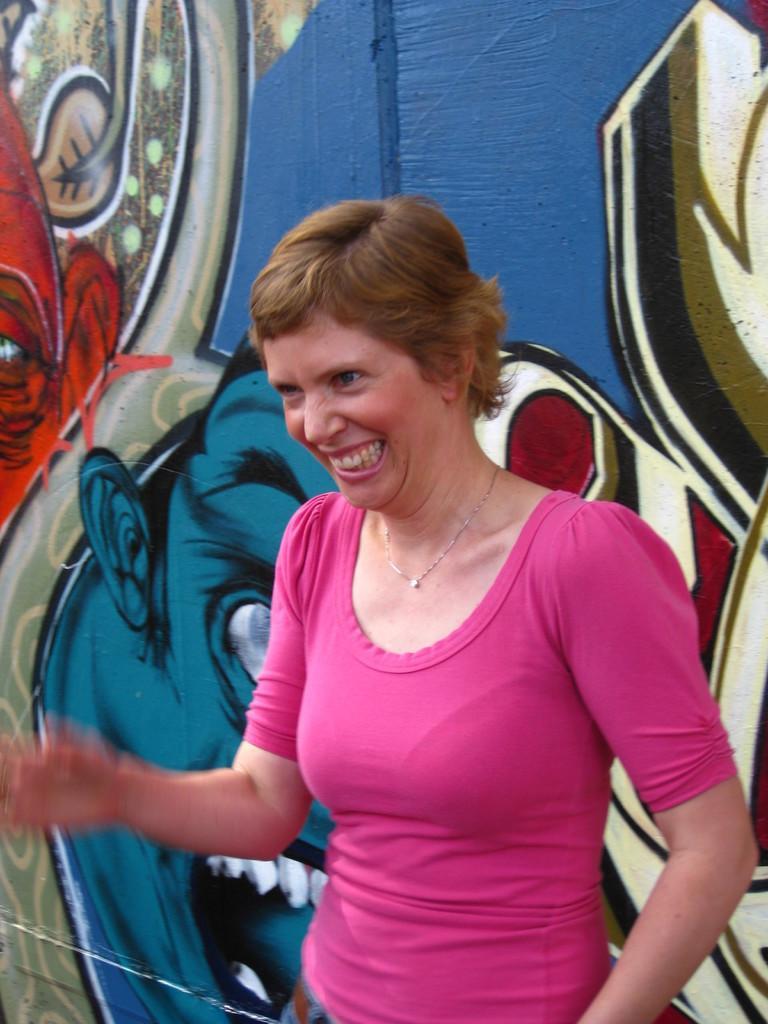Describe this image in one or two sentences. In the image we can see there is a lady standing and behind there is a wall. There is a painting on the wall. 